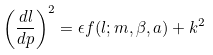<formula> <loc_0><loc_0><loc_500><loc_500>\left ( \frac { d l } { d p } \right ) ^ { 2 } = \epsilon f ( l ; m , \beta , a ) + k ^ { 2 }</formula> 